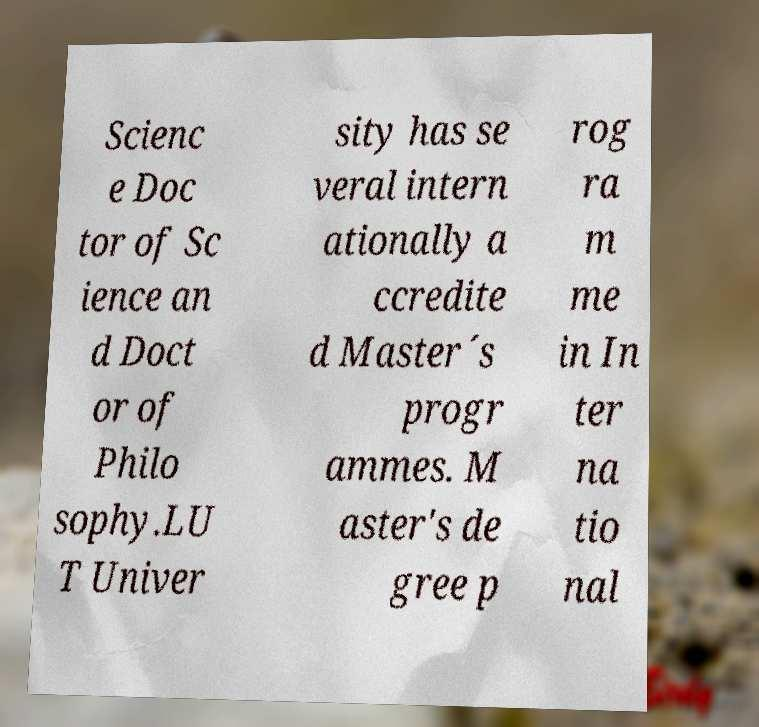Could you extract and type out the text from this image? Scienc e Doc tor of Sc ience an d Doct or of Philo sophy.LU T Univer sity has se veral intern ationally a ccredite d Master´s progr ammes. M aster's de gree p rog ra m me in In ter na tio nal 